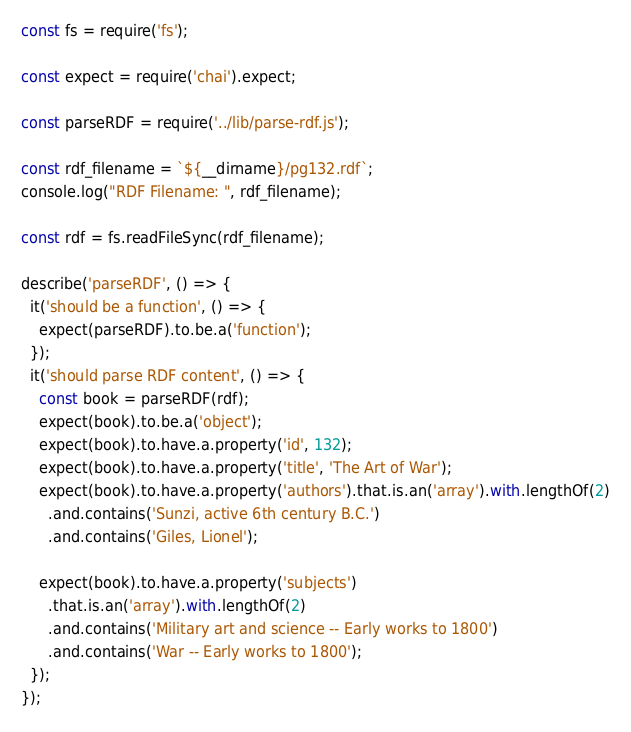Convert code to text. <code><loc_0><loc_0><loc_500><loc_500><_JavaScript_>
const fs = require('fs');

const expect = require('chai').expect;

const parseRDF = require('../lib/parse-rdf.js');

const rdf_filename = `${__dirname}/pg132.rdf`;
console.log("RDF Filename: ", rdf_filename);

const rdf = fs.readFileSync(rdf_filename);

describe('parseRDF', () => {
  it('should be a function', () => {
    expect(parseRDF).to.be.a('function');
  });
  it('should parse RDF content', () => {
    const book = parseRDF(rdf);
    expect(book).to.be.a('object');
    expect(book).to.have.a.property('id', 132);
    expect(book).to.have.a.property('title', 'The Art of War');
    expect(book).to.have.a.property('authors').that.is.an('array').with.lengthOf(2)
      .and.contains('Sunzi, active 6th century B.C.')
      .and.contains('Giles, Lionel');

    expect(book).to.have.a.property('subjects')
      .that.is.an('array').with.lengthOf(2)
      .and.contains('Military art and science -- Early works to 1800')
      .and.contains('War -- Early works to 1800');
  });
});</code> 